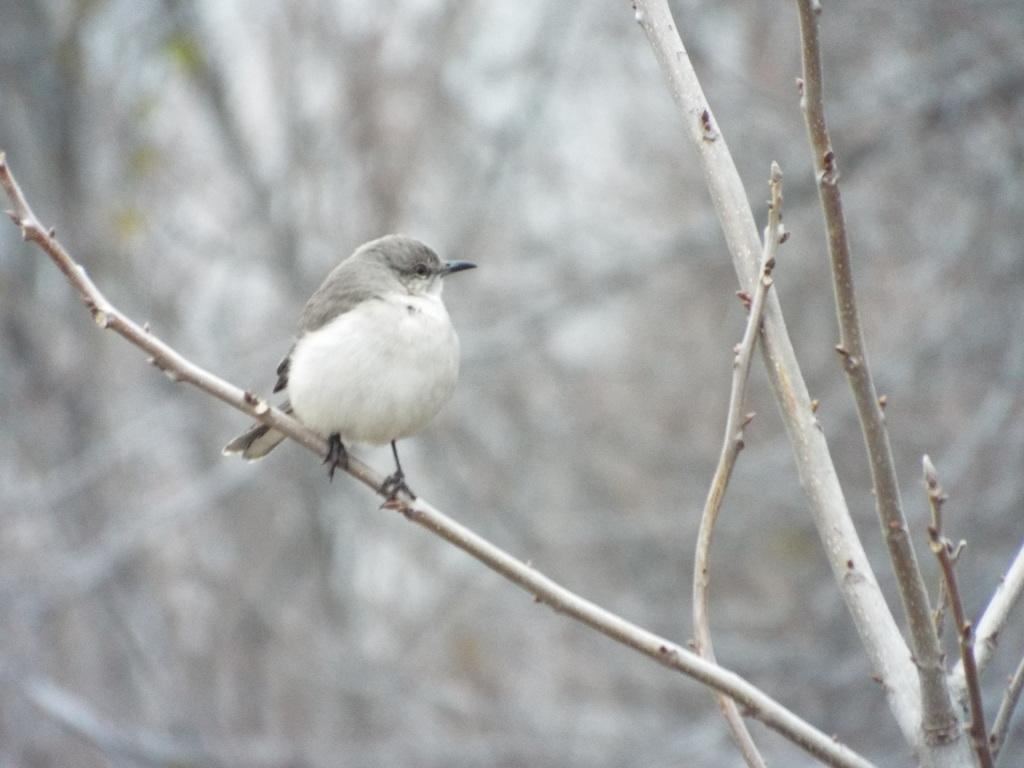What type of animal can be seen in the image? There is a bird in the image. Where is the bird located? The bird is on a stem of a tree. Can you describe the background of the image? The background of the image is blurred. How many birds are wearing hats in the image? There are no birds wearing hats in the image, as the bird is not wearing any clothing or accessories. Can you tell me how many calculators are visible in the image? There are no calculators present in the image. 